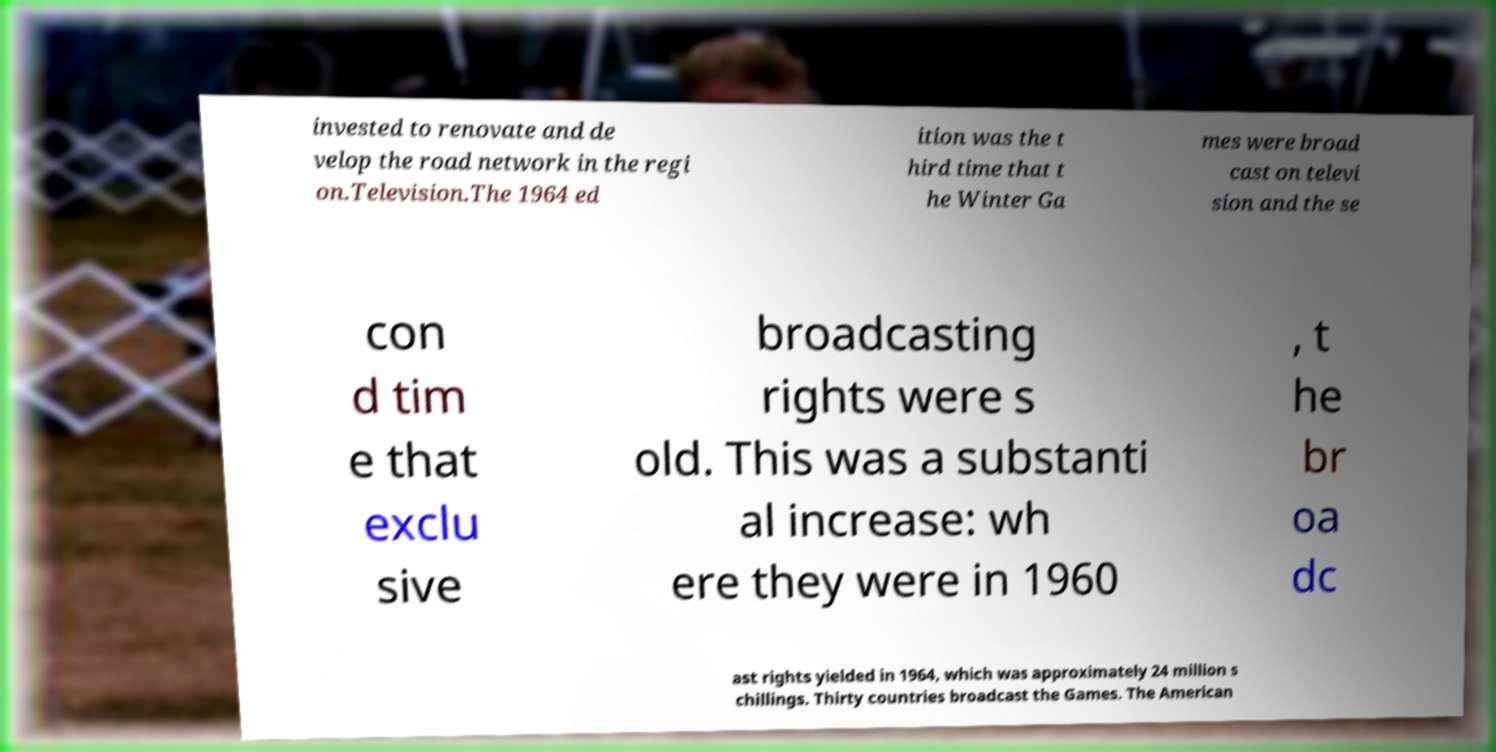Please read and relay the text visible in this image. What does it say? invested to renovate and de velop the road network in the regi on.Television.The 1964 ed ition was the t hird time that t he Winter Ga mes were broad cast on televi sion and the se con d tim e that exclu sive broadcasting rights were s old. This was a substanti al increase: wh ere they were in 1960 , t he br oa dc ast rights yielded in 1964, which was approximately 24 million s chillings. Thirty countries broadcast the Games. The American 